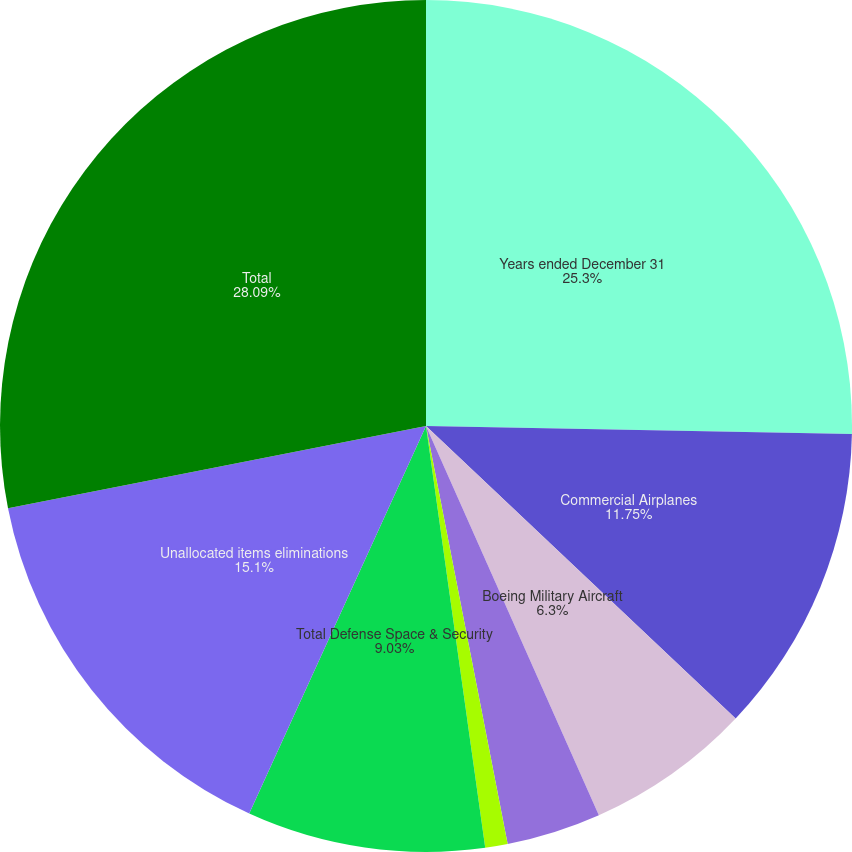<chart> <loc_0><loc_0><loc_500><loc_500><pie_chart><fcel>Years ended December 31<fcel>Commercial Airplanes<fcel>Boeing Military Aircraft<fcel>Network & Space Systems<fcel>Global Services & Support<fcel>Total Defense Space & Security<fcel>Unallocated items eliminations<fcel>Total<nl><fcel>25.3%<fcel>11.75%<fcel>6.3%<fcel>3.58%<fcel>0.85%<fcel>9.03%<fcel>15.1%<fcel>28.09%<nl></chart> 